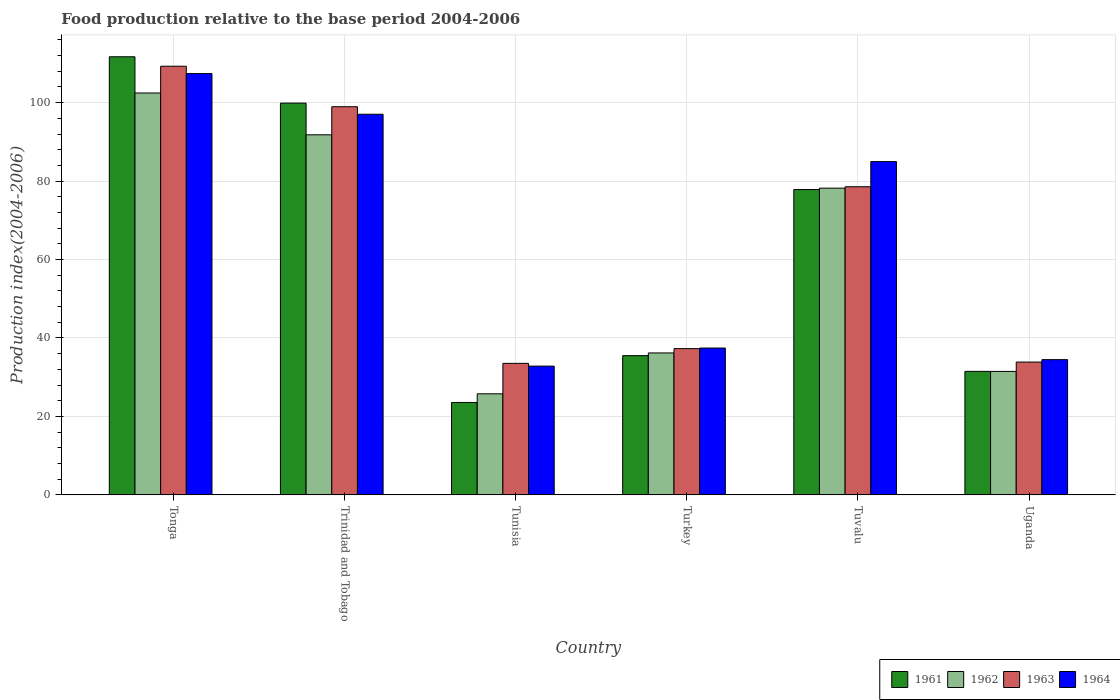How many different coloured bars are there?
Your answer should be compact. 4. How many groups of bars are there?
Make the answer very short. 6. Are the number of bars per tick equal to the number of legend labels?
Your response must be concise. Yes. How many bars are there on the 3rd tick from the left?
Offer a terse response. 4. How many bars are there on the 5th tick from the right?
Offer a very short reply. 4. What is the label of the 1st group of bars from the left?
Make the answer very short. Tonga. In how many cases, is the number of bars for a given country not equal to the number of legend labels?
Offer a terse response. 0. What is the food production index in 1961 in Tuvalu?
Your answer should be compact. 77.85. Across all countries, what is the maximum food production index in 1962?
Ensure brevity in your answer.  102.46. Across all countries, what is the minimum food production index in 1964?
Your answer should be compact. 32.83. In which country was the food production index in 1963 maximum?
Give a very brief answer. Tonga. In which country was the food production index in 1963 minimum?
Give a very brief answer. Tunisia. What is the total food production index in 1963 in the graph?
Your answer should be compact. 391.48. What is the difference between the food production index in 1962 in Trinidad and Tobago and that in Tuvalu?
Provide a succinct answer. 13.6. What is the difference between the food production index in 1961 in Tonga and the food production index in 1964 in Uganda?
Give a very brief answer. 77.21. What is the average food production index in 1961 per country?
Offer a terse response. 63.33. What is the difference between the food production index of/in 1963 and food production index of/in 1962 in Turkey?
Provide a succinct answer. 1.1. What is the ratio of the food production index in 1961 in Trinidad and Tobago to that in Turkey?
Provide a short and direct response. 2.81. What is the difference between the highest and the second highest food production index in 1961?
Ensure brevity in your answer.  22.03. What is the difference between the highest and the lowest food production index in 1961?
Keep it short and to the point. 88.13. In how many countries, is the food production index in 1963 greater than the average food production index in 1963 taken over all countries?
Give a very brief answer. 3. Is it the case that in every country, the sum of the food production index in 1963 and food production index in 1964 is greater than the sum of food production index in 1962 and food production index in 1961?
Offer a terse response. No. What does the 3rd bar from the left in Tonga represents?
Make the answer very short. 1963. What does the 4th bar from the right in Tuvalu represents?
Your answer should be compact. 1961. Is it the case that in every country, the sum of the food production index in 1962 and food production index in 1963 is greater than the food production index in 1961?
Provide a succinct answer. Yes. How many bars are there?
Make the answer very short. 24. Are all the bars in the graph horizontal?
Your answer should be compact. No. Does the graph contain any zero values?
Ensure brevity in your answer.  No. Does the graph contain grids?
Offer a terse response. Yes. Where does the legend appear in the graph?
Your answer should be very brief. Bottom right. How many legend labels are there?
Your answer should be compact. 4. What is the title of the graph?
Offer a terse response. Food production relative to the base period 2004-2006. What is the label or title of the X-axis?
Make the answer very short. Country. What is the label or title of the Y-axis?
Provide a short and direct response. Production index(2004-2006). What is the Production index(2004-2006) in 1961 in Tonga?
Your answer should be very brief. 111.69. What is the Production index(2004-2006) of 1962 in Tonga?
Keep it short and to the point. 102.46. What is the Production index(2004-2006) in 1963 in Tonga?
Make the answer very short. 109.28. What is the Production index(2004-2006) of 1964 in Tonga?
Offer a terse response. 107.41. What is the Production index(2004-2006) in 1961 in Trinidad and Tobago?
Offer a very short reply. 99.88. What is the Production index(2004-2006) of 1962 in Trinidad and Tobago?
Keep it short and to the point. 91.8. What is the Production index(2004-2006) in 1963 in Trinidad and Tobago?
Offer a very short reply. 98.96. What is the Production index(2004-2006) in 1964 in Trinidad and Tobago?
Your answer should be very brief. 97.04. What is the Production index(2004-2006) in 1961 in Tunisia?
Ensure brevity in your answer.  23.56. What is the Production index(2004-2006) in 1962 in Tunisia?
Make the answer very short. 25.77. What is the Production index(2004-2006) in 1963 in Tunisia?
Give a very brief answer. 33.53. What is the Production index(2004-2006) of 1964 in Tunisia?
Provide a short and direct response. 32.83. What is the Production index(2004-2006) in 1961 in Turkey?
Your answer should be very brief. 35.5. What is the Production index(2004-2006) in 1962 in Turkey?
Your answer should be very brief. 36.19. What is the Production index(2004-2006) of 1963 in Turkey?
Ensure brevity in your answer.  37.29. What is the Production index(2004-2006) in 1964 in Turkey?
Offer a very short reply. 37.44. What is the Production index(2004-2006) of 1961 in Tuvalu?
Provide a succinct answer. 77.85. What is the Production index(2004-2006) of 1962 in Tuvalu?
Your response must be concise. 78.2. What is the Production index(2004-2006) of 1963 in Tuvalu?
Your answer should be compact. 78.56. What is the Production index(2004-2006) in 1964 in Tuvalu?
Provide a short and direct response. 84.97. What is the Production index(2004-2006) of 1961 in Uganda?
Provide a succinct answer. 31.49. What is the Production index(2004-2006) in 1962 in Uganda?
Your response must be concise. 31.48. What is the Production index(2004-2006) of 1963 in Uganda?
Make the answer very short. 33.86. What is the Production index(2004-2006) of 1964 in Uganda?
Ensure brevity in your answer.  34.48. Across all countries, what is the maximum Production index(2004-2006) of 1961?
Provide a succinct answer. 111.69. Across all countries, what is the maximum Production index(2004-2006) in 1962?
Provide a succinct answer. 102.46. Across all countries, what is the maximum Production index(2004-2006) of 1963?
Make the answer very short. 109.28. Across all countries, what is the maximum Production index(2004-2006) of 1964?
Provide a succinct answer. 107.41. Across all countries, what is the minimum Production index(2004-2006) in 1961?
Offer a terse response. 23.56. Across all countries, what is the minimum Production index(2004-2006) in 1962?
Give a very brief answer. 25.77. Across all countries, what is the minimum Production index(2004-2006) of 1963?
Provide a succinct answer. 33.53. Across all countries, what is the minimum Production index(2004-2006) of 1964?
Give a very brief answer. 32.83. What is the total Production index(2004-2006) of 1961 in the graph?
Ensure brevity in your answer.  379.97. What is the total Production index(2004-2006) in 1962 in the graph?
Make the answer very short. 365.9. What is the total Production index(2004-2006) of 1963 in the graph?
Make the answer very short. 391.48. What is the total Production index(2004-2006) of 1964 in the graph?
Give a very brief answer. 394.17. What is the difference between the Production index(2004-2006) of 1961 in Tonga and that in Trinidad and Tobago?
Ensure brevity in your answer.  11.81. What is the difference between the Production index(2004-2006) of 1962 in Tonga and that in Trinidad and Tobago?
Your answer should be compact. 10.66. What is the difference between the Production index(2004-2006) of 1963 in Tonga and that in Trinidad and Tobago?
Offer a terse response. 10.32. What is the difference between the Production index(2004-2006) of 1964 in Tonga and that in Trinidad and Tobago?
Offer a terse response. 10.37. What is the difference between the Production index(2004-2006) of 1961 in Tonga and that in Tunisia?
Make the answer very short. 88.13. What is the difference between the Production index(2004-2006) in 1962 in Tonga and that in Tunisia?
Give a very brief answer. 76.69. What is the difference between the Production index(2004-2006) in 1963 in Tonga and that in Tunisia?
Your answer should be very brief. 75.75. What is the difference between the Production index(2004-2006) in 1964 in Tonga and that in Tunisia?
Your answer should be very brief. 74.58. What is the difference between the Production index(2004-2006) in 1961 in Tonga and that in Turkey?
Provide a short and direct response. 76.19. What is the difference between the Production index(2004-2006) of 1962 in Tonga and that in Turkey?
Keep it short and to the point. 66.27. What is the difference between the Production index(2004-2006) of 1963 in Tonga and that in Turkey?
Make the answer very short. 71.99. What is the difference between the Production index(2004-2006) in 1964 in Tonga and that in Turkey?
Give a very brief answer. 69.97. What is the difference between the Production index(2004-2006) in 1961 in Tonga and that in Tuvalu?
Make the answer very short. 33.84. What is the difference between the Production index(2004-2006) of 1962 in Tonga and that in Tuvalu?
Offer a very short reply. 24.26. What is the difference between the Production index(2004-2006) of 1963 in Tonga and that in Tuvalu?
Keep it short and to the point. 30.72. What is the difference between the Production index(2004-2006) in 1964 in Tonga and that in Tuvalu?
Offer a very short reply. 22.44. What is the difference between the Production index(2004-2006) in 1961 in Tonga and that in Uganda?
Provide a short and direct response. 80.2. What is the difference between the Production index(2004-2006) in 1962 in Tonga and that in Uganda?
Give a very brief answer. 70.98. What is the difference between the Production index(2004-2006) in 1963 in Tonga and that in Uganda?
Give a very brief answer. 75.42. What is the difference between the Production index(2004-2006) in 1964 in Tonga and that in Uganda?
Ensure brevity in your answer.  72.93. What is the difference between the Production index(2004-2006) of 1961 in Trinidad and Tobago and that in Tunisia?
Provide a short and direct response. 76.32. What is the difference between the Production index(2004-2006) of 1962 in Trinidad and Tobago and that in Tunisia?
Your response must be concise. 66.03. What is the difference between the Production index(2004-2006) in 1963 in Trinidad and Tobago and that in Tunisia?
Offer a very short reply. 65.43. What is the difference between the Production index(2004-2006) of 1964 in Trinidad and Tobago and that in Tunisia?
Make the answer very short. 64.21. What is the difference between the Production index(2004-2006) in 1961 in Trinidad and Tobago and that in Turkey?
Offer a terse response. 64.38. What is the difference between the Production index(2004-2006) of 1962 in Trinidad and Tobago and that in Turkey?
Your answer should be compact. 55.61. What is the difference between the Production index(2004-2006) in 1963 in Trinidad and Tobago and that in Turkey?
Your answer should be very brief. 61.67. What is the difference between the Production index(2004-2006) of 1964 in Trinidad and Tobago and that in Turkey?
Ensure brevity in your answer.  59.6. What is the difference between the Production index(2004-2006) in 1961 in Trinidad and Tobago and that in Tuvalu?
Your answer should be very brief. 22.03. What is the difference between the Production index(2004-2006) of 1963 in Trinidad and Tobago and that in Tuvalu?
Your answer should be compact. 20.4. What is the difference between the Production index(2004-2006) of 1964 in Trinidad and Tobago and that in Tuvalu?
Give a very brief answer. 12.07. What is the difference between the Production index(2004-2006) of 1961 in Trinidad and Tobago and that in Uganda?
Your answer should be compact. 68.39. What is the difference between the Production index(2004-2006) of 1962 in Trinidad and Tobago and that in Uganda?
Make the answer very short. 60.32. What is the difference between the Production index(2004-2006) of 1963 in Trinidad and Tobago and that in Uganda?
Offer a terse response. 65.1. What is the difference between the Production index(2004-2006) of 1964 in Trinidad and Tobago and that in Uganda?
Your answer should be compact. 62.56. What is the difference between the Production index(2004-2006) of 1961 in Tunisia and that in Turkey?
Keep it short and to the point. -11.94. What is the difference between the Production index(2004-2006) in 1962 in Tunisia and that in Turkey?
Give a very brief answer. -10.42. What is the difference between the Production index(2004-2006) in 1963 in Tunisia and that in Turkey?
Offer a terse response. -3.76. What is the difference between the Production index(2004-2006) of 1964 in Tunisia and that in Turkey?
Offer a very short reply. -4.61. What is the difference between the Production index(2004-2006) in 1961 in Tunisia and that in Tuvalu?
Offer a very short reply. -54.29. What is the difference between the Production index(2004-2006) of 1962 in Tunisia and that in Tuvalu?
Offer a terse response. -52.43. What is the difference between the Production index(2004-2006) in 1963 in Tunisia and that in Tuvalu?
Your answer should be compact. -45.03. What is the difference between the Production index(2004-2006) of 1964 in Tunisia and that in Tuvalu?
Provide a short and direct response. -52.14. What is the difference between the Production index(2004-2006) of 1961 in Tunisia and that in Uganda?
Provide a short and direct response. -7.93. What is the difference between the Production index(2004-2006) of 1962 in Tunisia and that in Uganda?
Your response must be concise. -5.71. What is the difference between the Production index(2004-2006) in 1963 in Tunisia and that in Uganda?
Ensure brevity in your answer.  -0.33. What is the difference between the Production index(2004-2006) in 1964 in Tunisia and that in Uganda?
Offer a very short reply. -1.65. What is the difference between the Production index(2004-2006) of 1961 in Turkey and that in Tuvalu?
Your answer should be very brief. -42.35. What is the difference between the Production index(2004-2006) in 1962 in Turkey and that in Tuvalu?
Keep it short and to the point. -42.01. What is the difference between the Production index(2004-2006) in 1963 in Turkey and that in Tuvalu?
Provide a short and direct response. -41.27. What is the difference between the Production index(2004-2006) in 1964 in Turkey and that in Tuvalu?
Provide a short and direct response. -47.53. What is the difference between the Production index(2004-2006) in 1961 in Turkey and that in Uganda?
Give a very brief answer. 4.01. What is the difference between the Production index(2004-2006) of 1962 in Turkey and that in Uganda?
Keep it short and to the point. 4.71. What is the difference between the Production index(2004-2006) of 1963 in Turkey and that in Uganda?
Offer a very short reply. 3.43. What is the difference between the Production index(2004-2006) in 1964 in Turkey and that in Uganda?
Keep it short and to the point. 2.96. What is the difference between the Production index(2004-2006) of 1961 in Tuvalu and that in Uganda?
Offer a terse response. 46.36. What is the difference between the Production index(2004-2006) of 1962 in Tuvalu and that in Uganda?
Offer a terse response. 46.72. What is the difference between the Production index(2004-2006) in 1963 in Tuvalu and that in Uganda?
Your response must be concise. 44.7. What is the difference between the Production index(2004-2006) in 1964 in Tuvalu and that in Uganda?
Your answer should be very brief. 50.49. What is the difference between the Production index(2004-2006) in 1961 in Tonga and the Production index(2004-2006) in 1962 in Trinidad and Tobago?
Make the answer very short. 19.89. What is the difference between the Production index(2004-2006) in 1961 in Tonga and the Production index(2004-2006) in 1963 in Trinidad and Tobago?
Offer a very short reply. 12.73. What is the difference between the Production index(2004-2006) of 1961 in Tonga and the Production index(2004-2006) of 1964 in Trinidad and Tobago?
Offer a very short reply. 14.65. What is the difference between the Production index(2004-2006) of 1962 in Tonga and the Production index(2004-2006) of 1964 in Trinidad and Tobago?
Provide a succinct answer. 5.42. What is the difference between the Production index(2004-2006) in 1963 in Tonga and the Production index(2004-2006) in 1964 in Trinidad and Tobago?
Provide a short and direct response. 12.24. What is the difference between the Production index(2004-2006) of 1961 in Tonga and the Production index(2004-2006) of 1962 in Tunisia?
Keep it short and to the point. 85.92. What is the difference between the Production index(2004-2006) in 1961 in Tonga and the Production index(2004-2006) in 1963 in Tunisia?
Offer a terse response. 78.16. What is the difference between the Production index(2004-2006) of 1961 in Tonga and the Production index(2004-2006) of 1964 in Tunisia?
Offer a terse response. 78.86. What is the difference between the Production index(2004-2006) in 1962 in Tonga and the Production index(2004-2006) in 1963 in Tunisia?
Your response must be concise. 68.93. What is the difference between the Production index(2004-2006) in 1962 in Tonga and the Production index(2004-2006) in 1964 in Tunisia?
Offer a very short reply. 69.63. What is the difference between the Production index(2004-2006) of 1963 in Tonga and the Production index(2004-2006) of 1964 in Tunisia?
Make the answer very short. 76.45. What is the difference between the Production index(2004-2006) in 1961 in Tonga and the Production index(2004-2006) in 1962 in Turkey?
Your answer should be very brief. 75.5. What is the difference between the Production index(2004-2006) of 1961 in Tonga and the Production index(2004-2006) of 1963 in Turkey?
Keep it short and to the point. 74.4. What is the difference between the Production index(2004-2006) of 1961 in Tonga and the Production index(2004-2006) of 1964 in Turkey?
Offer a terse response. 74.25. What is the difference between the Production index(2004-2006) in 1962 in Tonga and the Production index(2004-2006) in 1963 in Turkey?
Your answer should be very brief. 65.17. What is the difference between the Production index(2004-2006) of 1962 in Tonga and the Production index(2004-2006) of 1964 in Turkey?
Keep it short and to the point. 65.02. What is the difference between the Production index(2004-2006) of 1963 in Tonga and the Production index(2004-2006) of 1964 in Turkey?
Your answer should be very brief. 71.84. What is the difference between the Production index(2004-2006) in 1961 in Tonga and the Production index(2004-2006) in 1962 in Tuvalu?
Your answer should be compact. 33.49. What is the difference between the Production index(2004-2006) in 1961 in Tonga and the Production index(2004-2006) in 1963 in Tuvalu?
Offer a very short reply. 33.13. What is the difference between the Production index(2004-2006) in 1961 in Tonga and the Production index(2004-2006) in 1964 in Tuvalu?
Keep it short and to the point. 26.72. What is the difference between the Production index(2004-2006) of 1962 in Tonga and the Production index(2004-2006) of 1963 in Tuvalu?
Provide a short and direct response. 23.9. What is the difference between the Production index(2004-2006) in 1962 in Tonga and the Production index(2004-2006) in 1964 in Tuvalu?
Your answer should be compact. 17.49. What is the difference between the Production index(2004-2006) in 1963 in Tonga and the Production index(2004-2006) in 1964 in Tuvalu?
Offer a terse response. 24.31. What is the difference between the Production index(2004-2006) of 1961 in Tonga and the Production index(2004-2006) of 1962 in Uganda?
Your response must be concise. 80.21. What is the difference between the Production index(2004-2006) of 1961 in Tonga and the Production index(2004-2006) of 1963 in Uganda?
Make the answer very short. 77.83. What is the difference between the Production index(2004-2006) in 1961 in Tonga and the Production index(2004-2006) in 1964 in Uganda?
Your answer should be compact. 77.21. What is the difference between the Production index(2004-2006) of 1962 in Tonga and the Production index(2004-2006) of 1963 in Uganda?
Give a very brief answer. 68.6. What is the difference between the Production index(2004-2006) of 1962 in Tonga and the Production index(2004-2006) of 1964 in Uganda?
Give a very brief answer. 67.98. What is the difference between the Production index(2004-2006) in 1963 in Tonga and the Production index(2004-2006) in 1964 in Uganda?
Offer a terse response. 74.8. What is the difference between the Production index(2004-2006) in 1961 in Trinidad and Tobago and the Production index(2004-2006) in 1962 in Tunisia?
Your answer should be very brief. 74.11. What is the difference between the Production index(2004-2006) in 1961 in Trinidad and Tobago and the Production index(2004-2006) in 1963 in Tunisia?
Keep it short and to the point. 66.35. What is the difference between the Production index(2004-2006) of 1961 in Trinidad and Tobago and the Production index(2004-2006) of 1964 in Tunisia?
Keep it short and to the point. 67.05. What is the difference between the Production index(2004-2006) in 1962 in Trinidad and Tobago and the Production index(2004-2006) in 1963 in Tunisia?
Provide a succinct answer. 58.27. What is the difference between the Production index(2004-2006) of 1962 in Trinidad and Tobago and the Production index(2004-2006) of 1964 in Tunisia?
Make the answer very short. 58.97. What is the difference between the Production index(2004-2006) of 1963 in Trinidad and Tobago and the Production index(2004-2006) of 1964 in Tunisia?
Give a very brief answer. 66.13. What is the difference between the Production index(2004-2006) of 1961 in Trinidad and Tobago and the Production index(2004-2006) of 1962 in Turkey?
Your answer should be very brief. 63.69. What is the difference between the Production index(2004-2006) in 1961 in Trinidad and Tobago and the Production index(2004-2006) in 1963 in Turkey?
Your answer should be compact. 62.59. What is the difference between the Production index(2004-2006) in 1961 in Trinidad and Tobago and the Production index(2004-2006) in 1964 in Turkey?
Ensure brevity in your answer.  62.44. What is the difference between the Production index(2004-2006) of 1962 in Trinidad and Tobago and the Production index(2004-2006) of 1963 in Turkey?
Make the answer very short. 54.51. What is the difference between the Production index(2004-2006) of 1962 in Trinidad and Tobago and the Production index(2004-2006) of 1964 in Turkey?
Offer a very short reply. 54.36. What is the difference between the Production index(2004-2006) of 1963 in Trinidad and Tobago and the Production index(2004-2006) of 1964 in Turkey?
Ensure brevity in your answer.  61.52. What is the difference between the Production index(2004-2006) in 1961 in Trinidad and Tobago and the Production index(2004-2006) in 1962 in Tuvalu?
Your answer should be very brief. 21.68. What is the difference between the Production index(2004-2006) in 1961 in Trinidad and Tobago and the Production index(2004-2006) in 1963 in Tuvalu?
Your answer should be very brief. 21.32. What is the difference between the Production index(2004-2006) in 1961 in Trinidad and Tobago and the Production index(2004-2006) in 1964 in Tuvalu?
Your answer should be very brief. 14.91. What is the difference between the Production index(2004-2006) in 1962 in Trinidad and Tobago and the Production index(2004-2006) in 1963 in Tuvalu?
Your answer should be compact. 13.24. What is the difference between the Production index(2004-2006) in 1962 in Trinidad and Tobago and the Production index(2004-2006) in 1964 in Tuvalu?
Keep it short and to the point. 6.83. What is the difference between the Production index(2004-2006) of 1963 in Trinidad and Tobago and the Production index(2004-2006) of 1964 in Tuvalu?
Your response must be concise. 13.99. What is the difference between the Production index(2004-2006) in 1961 in Trinidad and Tobago and the Production index(2004-2006) in 1962 in Uganda?
Give a very brief answer. 68.4. What is the difference between the Production index(2004-2006) of 1961 in Trinidad and Tobago and the Production index(2004-2006) of 1963 in Uganda?
Your response must be concise. 66.02. What is the difference between the Production index(2004-2006) of 1961 in Trinidad and Tobago and the Production index(2004-2006) of 1964 in Uganda?
Offer a very short reply. 65.4. What is the difference between the Production index(2004-2006) in 1962 in Trinidad and Tobago and the Production index(2004-2006) in 1963 in Uganda?
Your answer should be compact. 57.94. What is the difference between the Production index(2004-2006) in 1962 in Trinidad and Tobago and the Production index(2004-2006) in 1964 in Uganda?
Provide a succinct answer. 57.32. What is the difference between the Production index(2004-2006) in 1963 in Trinidad and Tobago and the Production index(2004-2006) in 1964 in Uganda?
Offer a terse response. 64.48. What is the difference between the Production index(2004-2006) in 1961 in Tunisia and the Production index(2004-2006) in 1962 in Turkey?
Provide a succinct answer. -12.63. What is the difference between the Production index(2004-2006) in 1961 in Tunisia and the Production index(2004-2006) in 1963 in Turkey?
Your response must be concise. -13.73. What is the difference between the Production index(2004-2006) in 1961 in Tunisia and the Production index(2004-2006) in 1964 in Turkey?
Give a very brief answer. -13.88. What is the difference between the Production index(2004-2006) in 1962 in Tunisia and the Production index(2004-2006) in 1963 in Turkey?
Keep it short and to the point. -11.52. What is the difference between the Production index(2004-2006) in 1962 in Tunisia and the Production index(2004-2006) in 1964 in Turkey?
Ensure brevity in your answer.  -11.67. What is the difference between the Production index(2004-2006) of 1963 in Tunisia and the Production index(2004-2006) of 1964 in Turkey?
Offer a very short reply. -3.91. What is the difference between the Production index(2004-2006) of 1961 in Tunisia and the Production index(2004-2006) of 1962 in Tuvalu?
Offer a very short reply. -54.64. What is the difference between the Production index(2004-2006) in 1961 in Tunisia and the Production index(2004-2006) in 1963 in Tuvalu?
Offer a very short reply. -55. What is the difference between the Production index(2004-2006) of 1961 in Tunisia and the Production index(2004-2006) of 1964 in Tuvalu?
Your response must be concise. -61.41. What is the difference between the Production index(2004-2006) of 1962 in Tunisia and the Production index(2004-2006) of 1963 in Tuvalu?
Keep it short and to the point. -52.79. What is the difference between the Production index(2004-2006) of 1962 in Tunisia and the Production index(2004-2006) of 1964 in Tuvalu?
Provide a succinct answer. -59.2. What is the difference between the Production index(2004-2006) of 1963 in Tunisia and the Production index(2004-2006) of 1964 in Tuvalu?
Provide a short and direct response. -51.44. What is the difference between the Production index(2004-2006) of 1961 in Tunisia and the Production index(2004-2006) of 1962 in Uganda?
Ensure brevity in your answer.  -7.92. What is the difference between the Production index(2004-2006) in 1961 in Tunisia and the Production index(2004-2006) in 1964 in Uganda?
Your response must be concise. -10.92. What is the difference between the Production index(2004-2006) in 1962 in Tunisia and the Production index(2004-2006) in 1963 in Uganda?
Give a very brief answer. -8.09. What is the difference between the Production index(2004-2006) of 1962 in Tunisia and the Production index(2004-2006) of 1964 in Uganda?
Provide a short and direct response. -8.71. What is the difference between the Production index(2004-2006) in 1963 in Tunisia and the Production index(2004-2006) in 1964 in Uganda?
Give a very brief answer. -0.95. What is the difference between the Production index(2004-2006) of 1961 in Turkey and the Production index(2004-2006) of 1962 in Tuvalu?
Your answer should be compact. -42.7. What is the difference between the Production index(2004-2006) of 1961 in Turkey and the Production index(2004-2006) of 1963 in Tuvalu?
Keep it short and to the point. -43.06. What is the difference between the Production index(2004-2006) in 1961 in Turkey and the Production index(2004-2006) in 1964 in Tuvalu?
Offer a terse response. -49.47. What is the difference between the Production index(2004-2006) of 1962 in Turkey and the Production index(2004-2006) of 1963 in Tuvalu?
Keep it short and to the point. -42.37. What is the difference between the Production index(2004-2006) in 1962 in Turkey and the Production index(2004-2006) in 1964 in Tuvalu?
Give a very brief answer. -48.78. What is the difference between the Production index(2004-2006) in 1963 in Turkey and the Production index(2004-2006) in 1964 in Tuvalu?
Your response must be concise. -47.68. What is the difference between the Production index(2004-2006) of 1961 in Turkey and the Production index(2004-2006) of 1962 in Uganda?
Your answer should be very brief. 4.02. What is the difference between the Production index(2004-2006) of 1961 in Turkey and the Production index(2004-2006) of 1963 in Uganda?
Provide a short and direct response. 1.64. What is the difference between the Production index(2004-2006) of 1962 in Turkey and the Production index(2004-2006) of 1963 in Uganda?
Ensure brevity in your answer.  2.33. What is the difference between the Production index(2004-2006) in 1962 in Turkey and the Production index(2004-2006) in 1964 in Uganda?
Offer a terse response. 1.71. What is the difference between the Production index(2004-2006) in 1963 in Turkey and the Production index(2004-2006) in 1964 in Uganda?
Your response must be concise. 2.81. What is the difference between the Production index(2004-2006) in 1961 in Tuvalu and the Production index(2004-2006) in 1962 in Uganda?
Your response must be concise. 46.37. What is the difference between the Production index(2004-2006) of 1961 in Tuvalu and the Production index(2004-2006) of 1963 in Uganda?
Ensure brevity in your answer.  43.99. What is the difference between the Production index(2004-2006) of 1961 in Tuvalu and the Production index(2004-2006) of 1964 in Uganda?
Give a very brief answer. 43.37. What is the difference between the Production index(2004-2006) of 1962 in Tuvalu and the Production index(2004-2006) of 1963 in Uganda?
Offer a terse response. 44.34. What is the difference between the Production index(2004-2006) in 1962 in Tuvalu and the Production index(2004-2006) in 1964 in Uganda?
Give a very brief answer. 43.72. What is the difference between the Production index(2004-2006) of 1963 in Tuvalu and the Production index(2004-2006) of 1964 in Uganda?
Offer a terse response. 44.08. What is the average Production index(2004-2006) of 1961 per country?
Offer a terse response. 63.33. What is the average Production index(2004-2006) of 1962 per country?
Make the answer very short. 60.98. What is the average Production index(2004-2006) in 1963 per country?
Provide a succinct answer. 65.25. What is the average Production index(2004-2006) in 1964 per country?
Your answer should be compact. 65.69. What is the difference between the Production index(2004-2006) of 1961 and Production index(2004-2006) of 1962 in Tonga?
Your answer should be very brief. 9.23. What is the difference between the Production index(2004-2006) of 1961 and Production index(2004-2006) of 1963 in Tonga?
Give a very brief answer. 2.41. What is the difference between the Production index(2004-2006) of 1961 and Production index(2004-2006) of 1964 in Tonga?
Provide a short and direct response. 4.28. What is the difference between the Production index(2004-2006) of 1962 and Production index(2004-2006) of 1963 in Tonga?
Your response must be concise. -6.82. What is the difference between the Production index(2004-2006) of 1962 and Production index(2004-2006) of 1964 in Tonga?
Your answer should be compact. -4.95. What is the difference between the Production index(2004-2006) of 1963 and Production index(2004-2006) of 1964 in Tonga?
Offer a terse response. 1.87. What is the difference between the Production index(2004-2006) of 1961 and Production index(2004-2006) of 1962 in Trinidad and Tobago?
Make the answer very short. 8.08. What is the difference between the Production index(2004-2006) in 1961 and Production index(2004-2006) in 1964 in Trinidad and Tobago?
Offer a very short reply. 2.84. What is the difference between the Production index(2004-2006) in 1962 and Production index(2004-2006) in 1963 in Trinidad and Tobago?
Give a very brief answer. -7.16. What is the difference between the Production index(2004-2006) of 1962 and Production index(2004-2006) of 1964 in Trinidad and Tobago?
Provide a short and direct response. -5.24. What is the difference between the Production index(2004-2006) of 1963 and Production index(2004-2006) of 1964 in Trinidad and Tobago?
Offer a terse response. 1.92. What is the difference between the Production index(2004-2006) of 1961 and Production index(2004-2006) of 1962 in Tunisia?
Your answer should be very brief. -2.21. What is the difference between the Production index(2004-2006) of 1961 and Production index(2004-2006) of 1963 in Tunisia?
Give a very brief answer. -9.97. What is the difference between the Production index(2004-2006) of 1961 and Production index(2004-2006) of 1964 in Tunisia?
Your answer should be very brief. -9.27. What is the difference between the Production index(2004-2006) of 1962 and Production index(2004-2006) of 1963 in Tunisia?
Offer a very short reply. -7.76. What is the difference between the Production index(2004-2006) in 1962 and Production index(2004-2006) in 1964 in Tunisia?
Give a very brief answer. -7.06. What is the difference between the Production index(2004-2006) of 1963 and Production index(2004-2006) of 1964 in Tunisia?
Provide a succinct answer. 0.7. What is the difference between the Production index(2004-2006) of 1961 and Production index(2004-2006) of 1962 in Turkey?
Your response must be concise. -0.69. What is the difference between the Production index(2004-2006) in 1961 and Production index(2004-2006) in 1963 in Turkey?
Offer a terse response. -1.79. What is the difference between the Production index(2004-2006) in 1961 and Production index(2004-2006) in 1964 in Turkey?
Give a very brief answer. -1.94. What is the difference between the Production index(2004-2006) in 1962 and Production index(2004-2006) in 1963 in Turkey?
Offer a terse response. -1.1. What is the difference between the Production index(2004-2006) in 1962 and Production index(2004-2006) in 1964 in Turkey?
Provide a short and direct response. -1.25. What is the difference between the Production index(2004-2006) in 1963 and Production index(2004-2006) in 1964 in Turkey?
Ensure brevity in your answer.  -0.15. What is the difference between the Production index(2004-2006) of 1961 and Production index(2004-2006) of 1962 in Tuvalu?
Offer a very short reply. -0.35. What is the difference between the Production index(2004-2006) of 1961 and Production index(2004-2006) of 1963 in Tuvalu?
Your answer should be very brief. -0.71. What is the difference between the Production index(2004-2006) in 1961 and Production index(2004-2006) in 1964 in Tuvalu?
Ensure brevity in your answer.  -7.12. What is the difference between the Production index(2004-2006) in 1962 and Production index(2004-2006) in 1963 in Tuvalu?
Offer a terse response. -0.36. What is the difference between the Production index(2004-2006) in 1962 and Production index(2004-2006) in 1964 in Tuvalu?
Ensure brevity in your answer.  -6.77. What is the difference between the Production index(2004-2006) in 1963 and Production index(2004-2006) in 1964 in Tuvalu?
Give a very brief answer. -6.41. What is the difference between the Production index(2004-2006) in 1961 and Production index(2004-2006) in 1963 in Uganda?
Provide a short and direct response. -2.37. What is the difference between the Production index(2004-2006) in 1961 and Production index(2004-2006) in 1964 in Uganda?
Your answer should be very brief. -2.99. What is the difference between the Production index(2004-2006) in 1962 and Production index(2004-2006) in 1963 in Uganda?
Your answer should be very brief. -2.38. What is the difference between the Production index(2004-2006) in 1962 and Production index(2004-2006) in 1964 in Uganda?
Make the answer very short. -3. What is the difference between the Production index(2004-2006) in 1963 and Production index(2004-2006) in 1964 in Uganda?
Ensure brevity in your answer.  -0.62. What is the ratio of the Production index(2004-2006) in 1961 in Tonga to that in Trinidad and Tobago?
Your response must be concise. 1.12. What is the ratio of the Production index(2004-2006) in 1962 in Tonga to that in Trinidad and Tobago?
Offer a very short reply. 1.12. What is the ratio of the Production index(2004-2006) in 1963 in Tonga to that in Trinidad and Tobago?
Offer a very short reply. 1.1. What is the ratio of the Production index(2004-2006) in 1964 in Tonga to that in Trinidad and Tobago?
Your response must be concise. 1.11. What is the ratio of the Production index(2004-2006) of 1961 in Tonga to that in Tunisia?
Your response must be concise. 4.74. What is the ratio of the Production index(2004-2006) of 1962 in Tonga to that in Tunisia?
Your answer should be compact. 3.98. What is the ratio of the Production index(2004-2006) in 1963 in Tonga to that in Tunisia?
Keep it short and to the point. 3.26. What is the ratio of the Production index(2004-2006) of 1964 in Tonga to that in Tunisia?
Your answer should be very brief. 3.27. What is the ratio of the Production index(2004-2006) in 1961 in Tonga to that in Turkey?
Make the answer very short. 3.15. What is the ratio of the Production index(2004-2006) in 1962 in Tonga to that in Turkey?
Make the answer very short. 2.83. What is the ratio of the Production index(2004-2006) of 1963 in Tonga to that in Turkey?
Your answer should be compact. 2.93. What is the ratio of the Production index(2004-2006) in 1964 in Tonga to that in Turkey?
Your response must be concise. 2.87. What is the ratio of the Production index(2004-2006) in 1961 in Tonga to that in Tuvalu?
Give a very brief answer. 1.43. What is the ratio of the Production index(2004-2006) in 1962 in Tonga to that in Tuvalu?
Give a very brief answer. 1.31. What is the ratio of the Production index(2004-2006) in 1963 in Tonga to that in Tuvalu?
Your answer should be very brief. 1.39. What is the ratio of the Production index(2004-2006) in 1964 in Tonga to that in Tuvalu?
Offer a very short reply. 1.26. What is the ratio of the Production index(2004-2006) of 1961 in Tonga to that in Uganda?
Give a very brief answer. 3.55. What is the ratio of the Production index(2004-2006) in 1962 in Tonga to that in Uganda?
Your response must be concise. 3.25. What is the ratio of the Production index(2004-2006) of 1963 in Tonga to that in Uganda?
Offer a very short reply. 3.23. What is the ratio of the Production index(2004-2006) of 1964 in Tonga to that in Uganda?
Provide a short and direct response. 3.12. What is the ratio of the Production index(2004-2006) in 1961 in Trinidad and Tobago to that in Tunisia?
Your answer should be very brief. 4.24. What is the ratio of the Production index(2004-2006) in 1962 in Trinidad and Tobago to that in Tunisia?
Your answer should be very brief. 3.56. What is the ratio of the Production index(2004-2006) in 1963 in Trinidad and Tobago to that in Tunisia?
Offer a terse response. 2.95. What is the ratio of the Production index(2004-2006) in 1964 in Trinidad and Tobago to that in Tunisia?
Provide a succinct answer. 2.96. What is the ratio of the Production index(2004-2006) of 1961 in Trinidad and Tobago to that in Turkey?
Offer a very short reply. 2.81. What is the ratio of the Production index(2004-2006) in 1962 in Trinidad and Tobago to that in Turkey?
Offer a terse response. 2.54. What is the ratio of the Production index(2004-2006) in 1963 in Trinidad and Tobago to that in Turkey?
Offer a terse response. 2.65. What is the ratio of the Production index(2004-2006) of 1964 in Trinidad and Tobago to that in Turkey?
Ensure brevity in your answer.  2.59. What is the ratio of the Production index(2004-2006) in 1961 in Trinidad and Tobago to that in Tuvalu?
Make the answer very short. 1.28. What is the ratio of the Production index(2004-2006) in 1962 in Trinidad and Tobago to that in Tuvalu?
Your answer should be compact. 1.17. What is the ratio of the Production index(2004-2006) of 1963 in Trinidad and Tobago to that in Tuvalu?
Offer a very short reply. 1.26. What is the ratio of the Production index(2004-2006) of 1964 in Trinidad and Tobago to that in Tuvalu?
Your answer should be very brief. 1.14. What is the ratio of the Production index(2004-2006) of 1961 in Trinidad and Tobago to that in Uganda?
Your answer should be compact. 3.17. What is the ratio of the Production index(2004-2006) of 1962 in Trinidad and Tobago to that in Uganda?
Your answer should be compact. 2.92. What is the ratio of the Production index(2004-2006) of 1963 in Trinidad and Tobago to that in Uganda?
Keep it short and to the point. 2.92. What is the ratio of the Production index(2004-2006) of 1964 in Trinidad and Tobago to that in Uganda?
Offer a terse response. 2.81. What is the ratio of the Production index(2004-2006) in 1961 in Tunisia to that in Turkey?
Offer a very short reply. 0.66. What is the ratio of the Production index(2004-2006) in 1962 in Tunisia to that in Turkey?
Your answer should be very brief. 0.71. What is the ratio of the Production index(2004-2006) in 1963 in Tunisia to that in Turkey?
Give a very brief answer. 0.9. What is the ratio of the Production index(2004-2006) of 1964 in Tunisia to that in Turkey?
Give a very brief answer. 0.88. What is the ratio of the Production index(2004-2006) of 1961 in Tunisia to that in Tuvalu?
Provide a short and direct response. 0.3. What is the ratio of the Production index(2004-2006) in 1962 in Tunisia to that in Tuvalu?
Ensure brevity in your answer.  0.33. What is the ratio of the Production index(2004-2006) in 1963 in Tunisia to that in Tuvalu?
Ensure brevity in your answer.  0.43. What is the ratio of the Production index(2004-2006) of 1964 in Tunisia to that in Tuvalu?
Your answer should be compact. 0.39. What is the ratio of the Production index(2004-2006) in 1961 in Tunisia to that in Uganda?
Keep it short and to the point. 0.75. What is the ratio of the Production index(2004-2006) in 1962 in Tunisia to that in Uganda?
Ensure brevity in your answer.  0.82. What is the ratio of the Production index(2004-2006) of 1963 in Tunisia to that in Uganda?
Your answer should be very brief. 0.99. What is the ratio of the Production index(2004-2006) of 1964 in Tunisia to that in Uganda?
Make the answer very short. 0.95. What is the ratio of the Production index(2004-2006) of 1961 in Turkey to that in Tuvalu?
Give a very brief answer. 0.46. What is the ratio of the Production index(2004-2006) in 1962 in Turkey to that in Tuvalu?
Provide a succinct answer. 0.46. What is the ratio of the Production index(2004-2006) in 1963 in Turkey to that in Tuvalu?
Provide a short and direct response. 0.47. What is the ratio of the Production index(2004-2006) in 1964 in Turkey to that in Tuvalu?
Offer a very short reply. 0.44. What is the ratio of the Production index(2004-2006) of 1961 in Turkey to that in Uganda?
Provide a short and direct response. 1.13. What is the ratio of the Production index(2004-2006) in 1962 in Turkey to that in Uganda?
Offer a terse response. 1.15. What is the ratio of the Production index(2004-2006) of 1963 in Turkey to that in Uganda?
Provide a short and direct response. 1.1. What is the ratio of the Production index(2004-2006) in 1964 in Turkey to that in Uganda?
Provide a succinct answer. 1.09. What is the ratio of the Production index(2004-2006) in 1961 in Tuvalu to that in Uganda?
Your answer should be very brief. 2.47. What is the ratio of the Production index(2004-2006) in 1962 in Tuvalu to that in Uganda?
Your answer should be very brief. 2.48. What is the ratio of the Production index(2004-2006) of 1963 in Tuvalu to that in Uganda?
Provide a succinct answer. 2.32. What is the ratio of the Production index(2004-2006) in 1964 in Tuvalu to that in Uganda?
Make the answer very short. 2.46. What is the difference between the highest and the second highest Production index(2004-2006) in 1961?
Provide a short and direct response. 11.81. What is the difference between the highest and the second highest Production index(2004-2006) of 1962?
Offer a very short reply. 10.66. What is the difference between the highest and the second highest Production index(2004-2006) of 1963?
Provide a succinct answer. 10.32. What is the difference between the highest and the second highest Production index(2004-2006) in 1964?
Provide a succinct answer. 10.37. What is the difference between the highest and the lowest Production index(2004-2006) in 1961?
Your answer should be very brief. 88.13. What is the difference between the highest and the lowest Production index(2004-2006) in 1962?
Provide a short and direct response. 76.69. What is the difference between the highest and the lowest Production index(2004-2006) in 1963?
Give a very brief answer. 75.75. What is the difference between the highest and the lowest Production index(2004-2006) of 1964?
Ensure brevity in your answer.  74.58. 